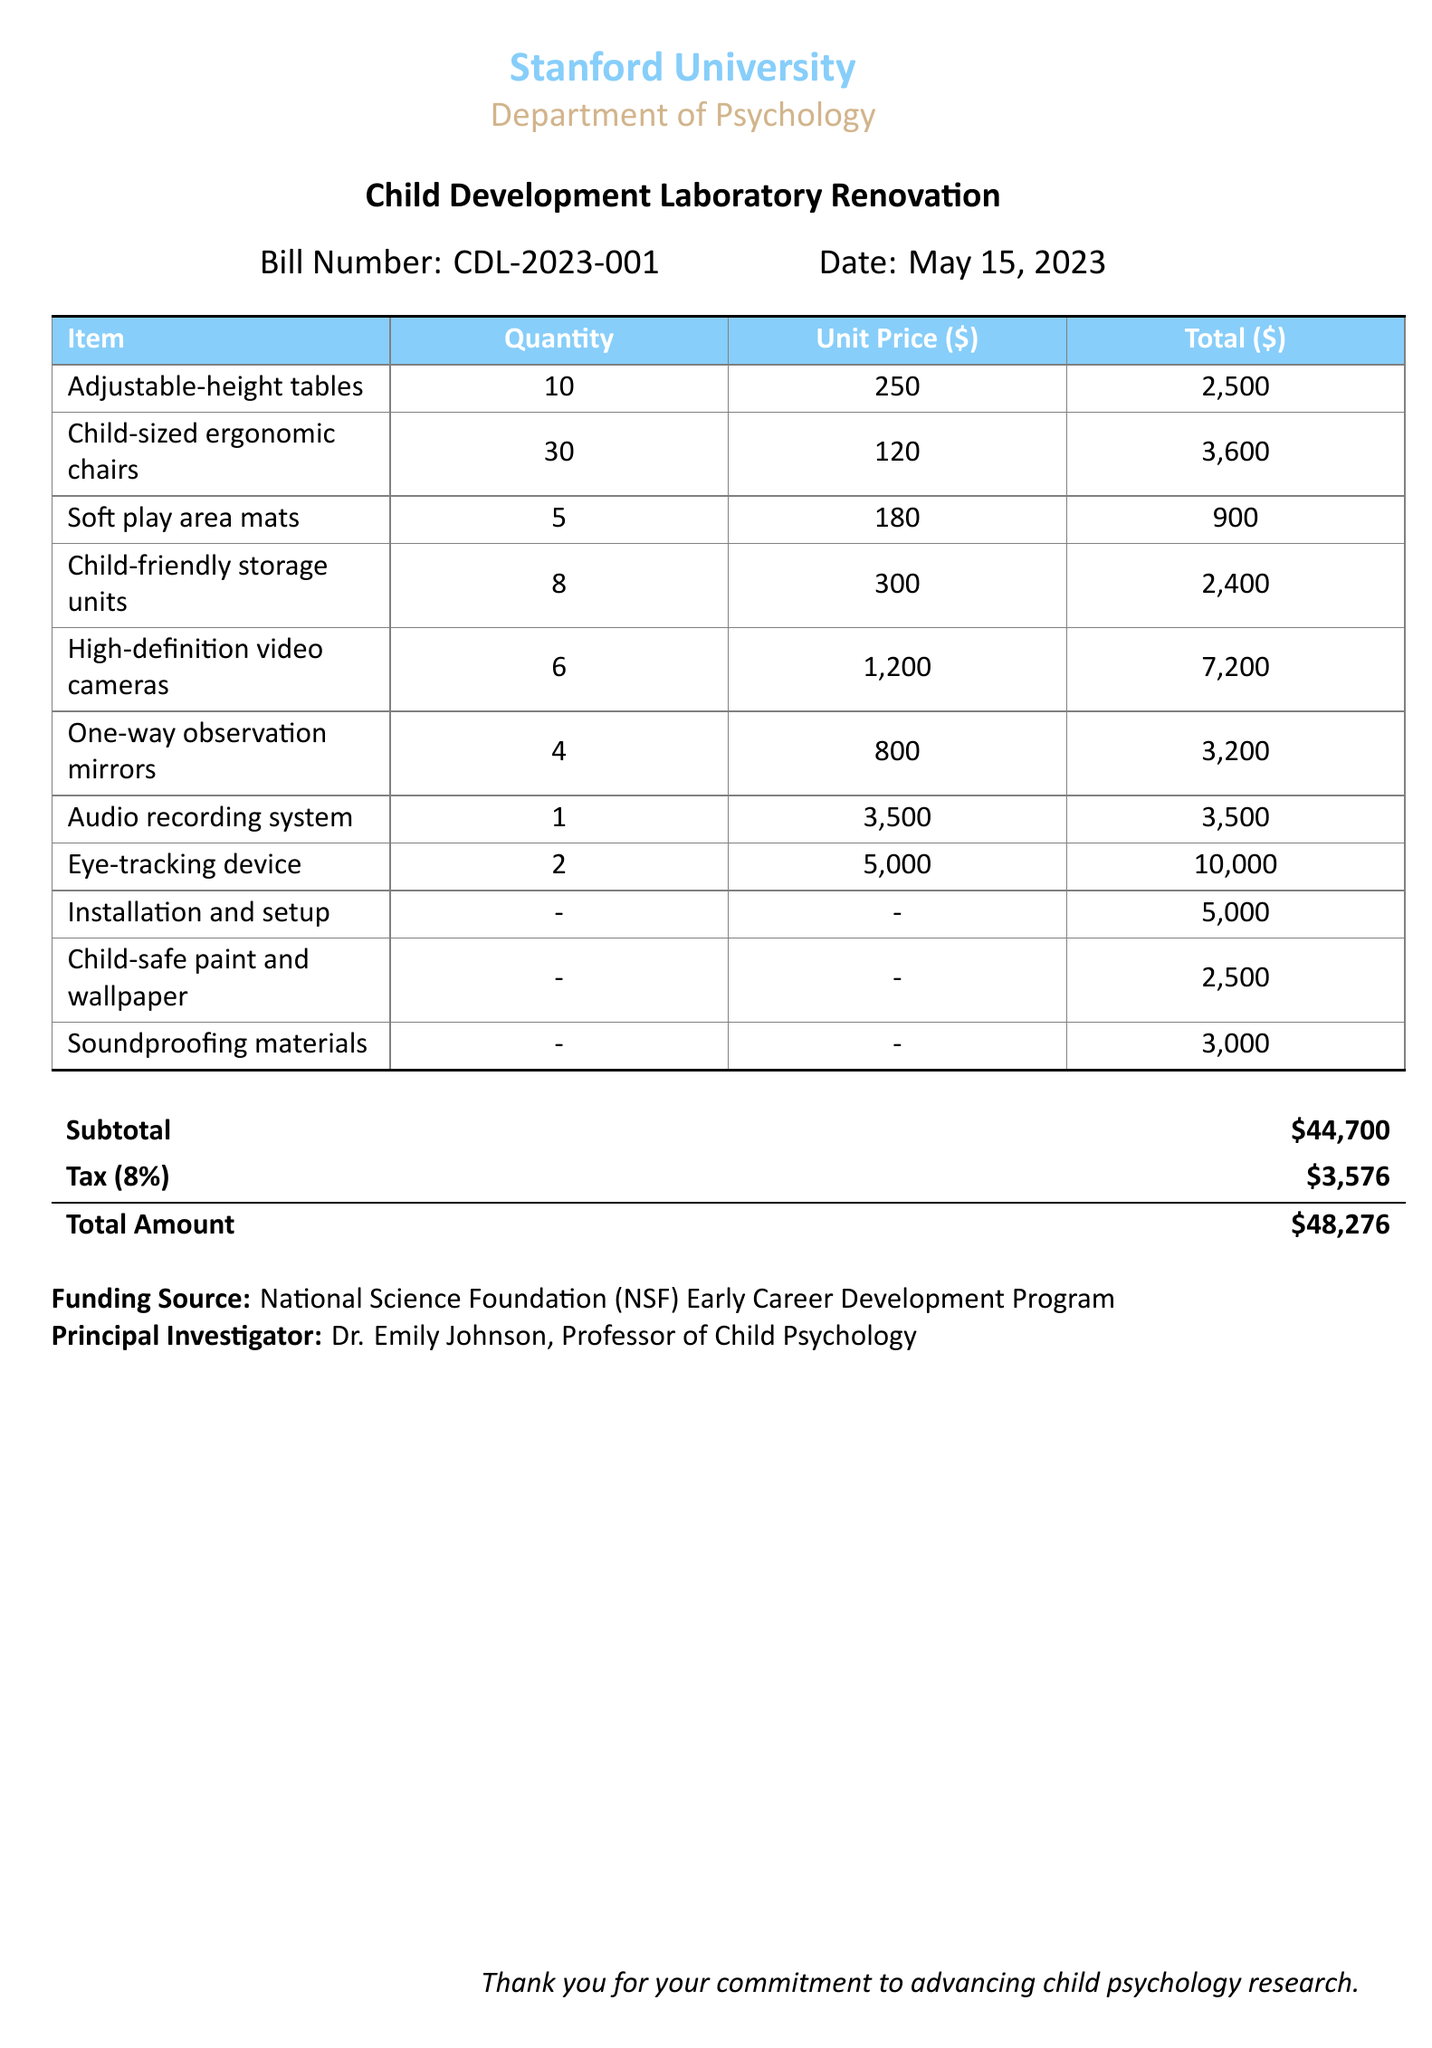What is the bill number? The bill number is indicated at the top of the document under "Bill Number."
Answer: CDL-2023-001 What is the total amount of the renovation project? The total amount is calculated by adding the subtotal and tax, shown in the document.
Answer: $48,276 Who is the principal investigator? The principal investigator's name is listed at the bottom of the document.
Answer: Dr. Emily Johnson How many high-definition video cameras are included? The quantity of each item is specified in the table.
Answer: 6 What is the cost of child-friendly storage units? The cost per item for child-friendly storage units is shown in the itemized list.
Answer: $2,400 What percentage tax is applied in the bill? The tax percentage is mentioned in the subtotal section of the document.
Answer: 8% How many child-sized ergonomic chairs are required? The quantity needed for each item is stated in the table.
Answer: 30 What is the funding source for this project? The funding source is explicitly mentioned in the document.
Answer: National Science Foundation (NSF) Early Career Development Program What types of observation equipment are included in the bill? The observation equipment consists of items listed in the table, which can be referenced.
Answer: One-way observation mirrors, Eye-tracking device, Audio recording system 